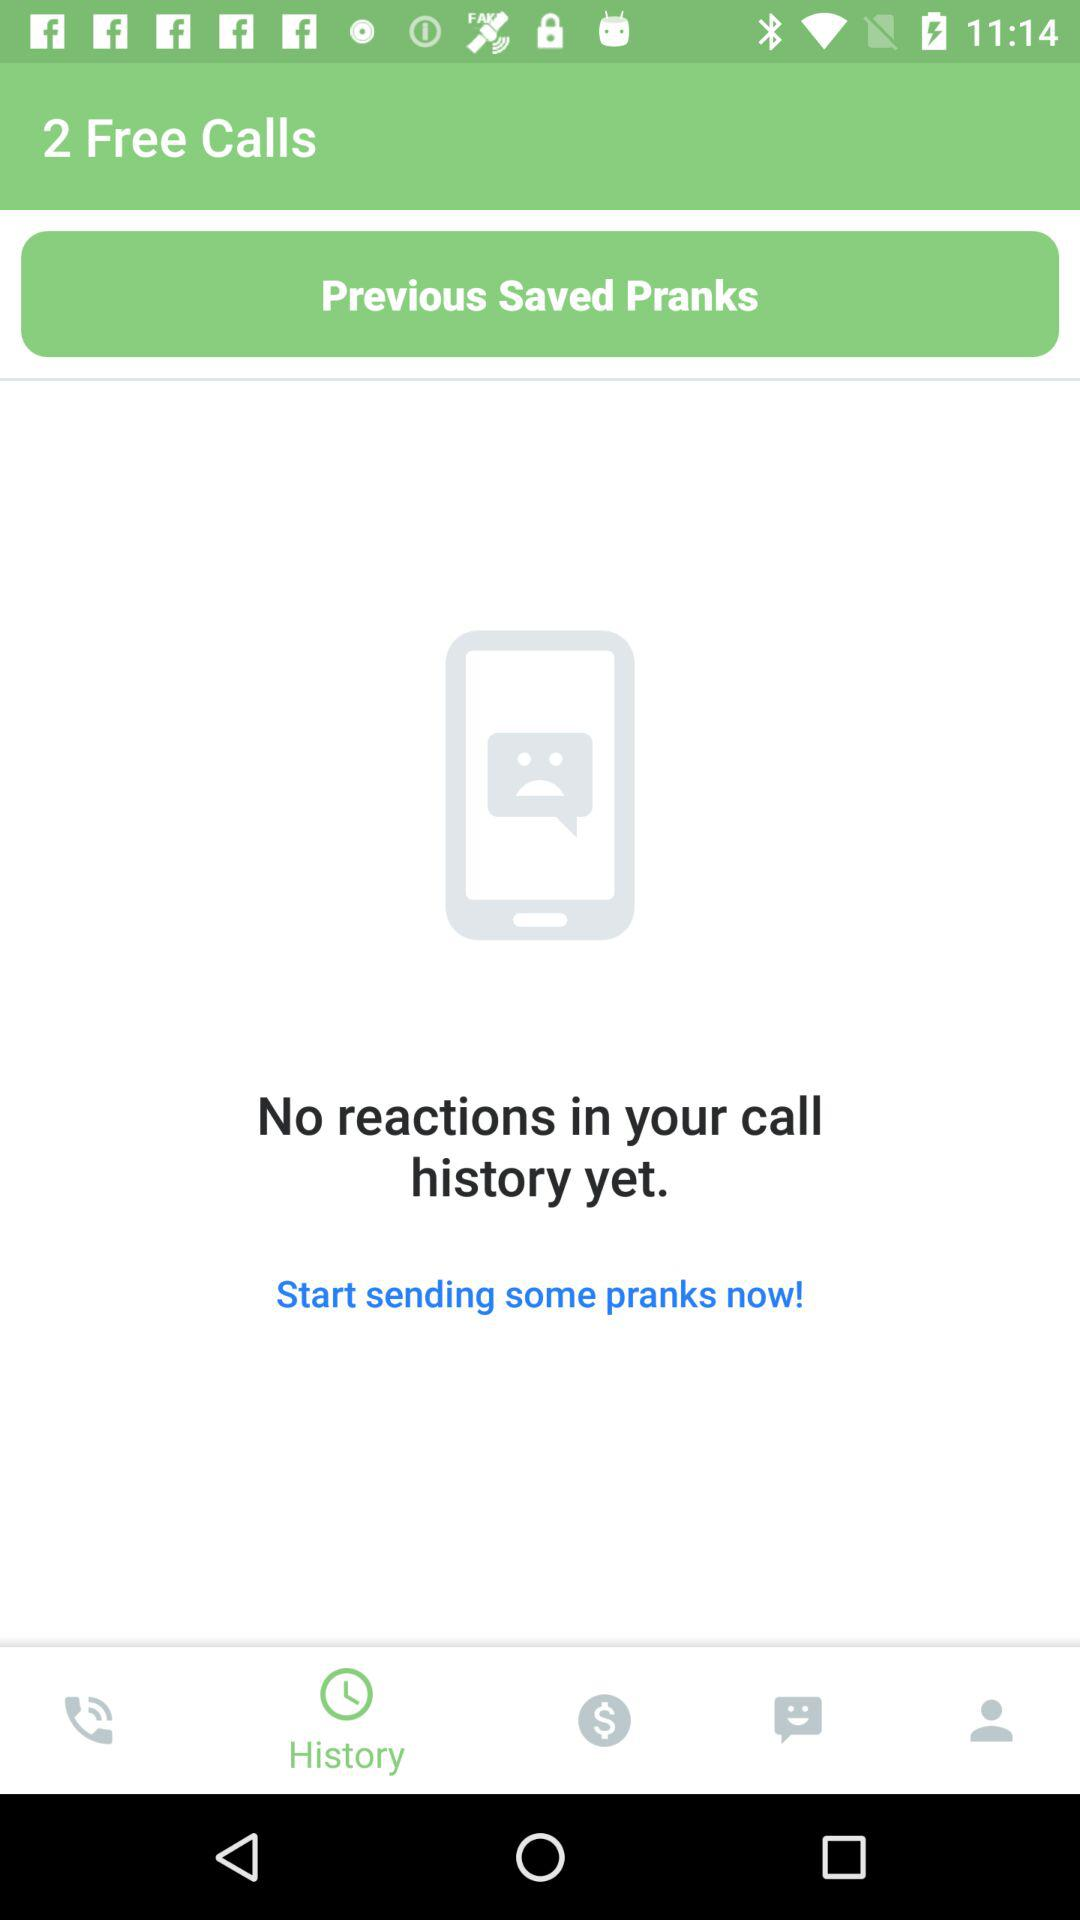How many calls are free? There are 2 free calls. 